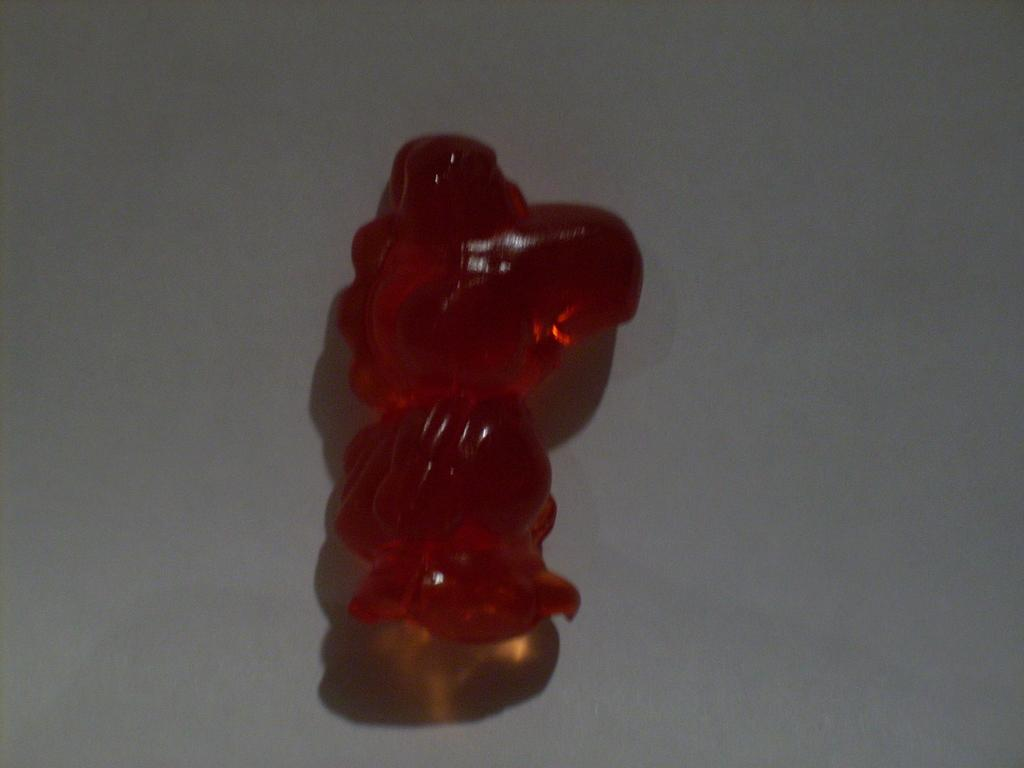What is the color of the object in the image? The object in the image is red. What is the object on top of? The red object is on a white surface. What type of horn can be seen on the red object in the image? There is no horn present on the red object in the image. 